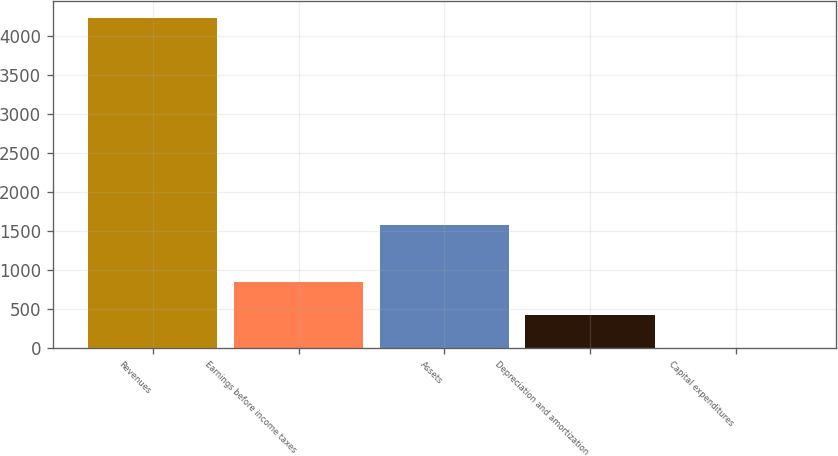<chart> <loc_0><loc_0><loc_500><loc_500><bar_chart><fcel>Revenues<fcel>Earnings before income taxes<fcel>Assets<fcel>Depreciation and amortization<fcel>Capital expenditures<nl><fcel>4242.7<fcel>848.7<fcel>1584.1<fcel>424.45<fcel>0.2<nl></chart> 